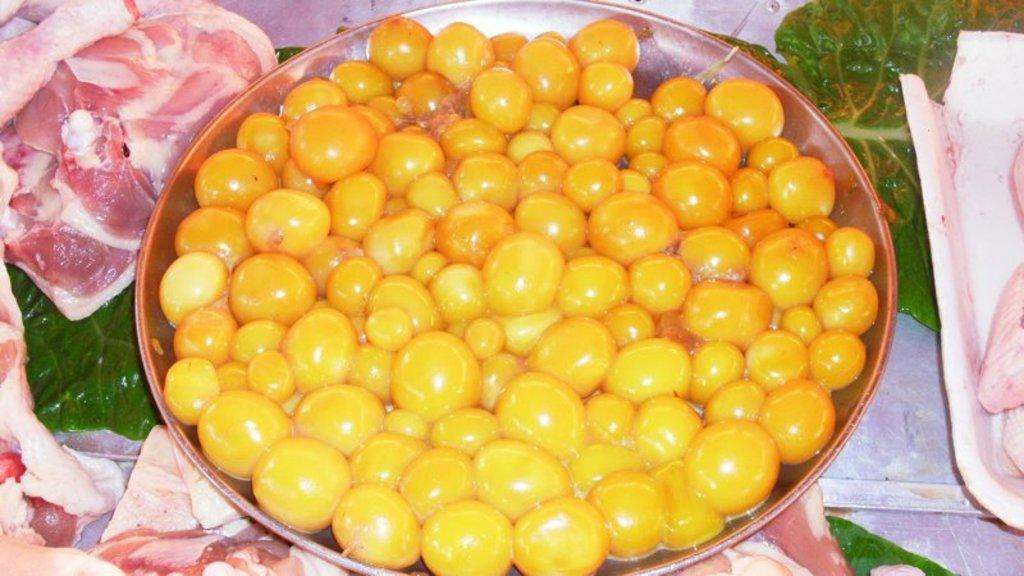What is on the plate in the image? There is food on the plate in the image. Can you describe the meat in the image? There is meat in trays on both sides of the image. How does the fish contribute to the debt in the image? There is no fish or mention of debt in the image; it only features food on a plate and meat in trays. 